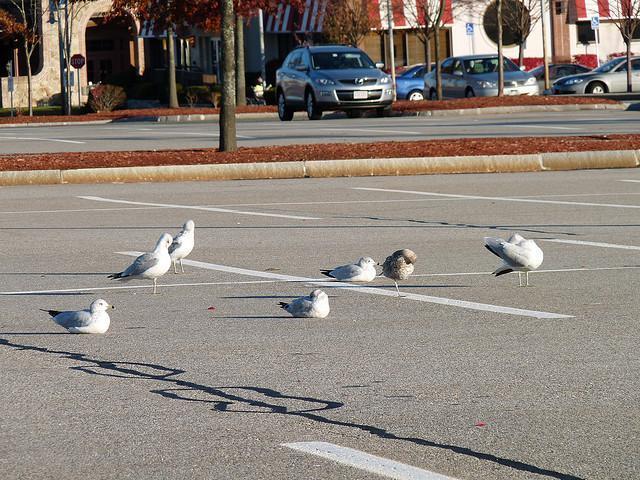How many cars are in the photo?
Give a very brief answer. 3. 